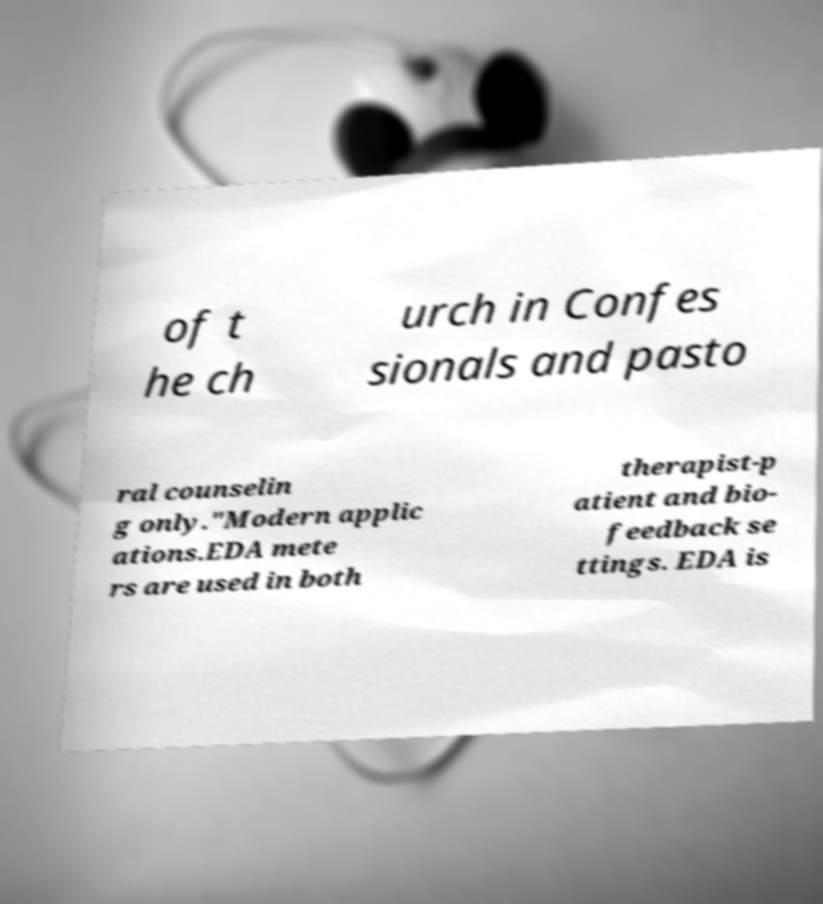For documentation purposes, I need the text within this image transcribed. Could you provide that? of t he ch urch in Confes sionals and pasto ral counselin g only."Modern applic ations.EDA mete rs are used in both therapist-p atient and bio- feedback se ttings. EDA is 